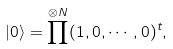<formula> <loc_0><loc_0><loc_500><loc_500>| 0 \rangle = \prod ^ { \otimes N } ( 1 , 0 , \cdots , 0 ) ^ { t } ,</formula> 